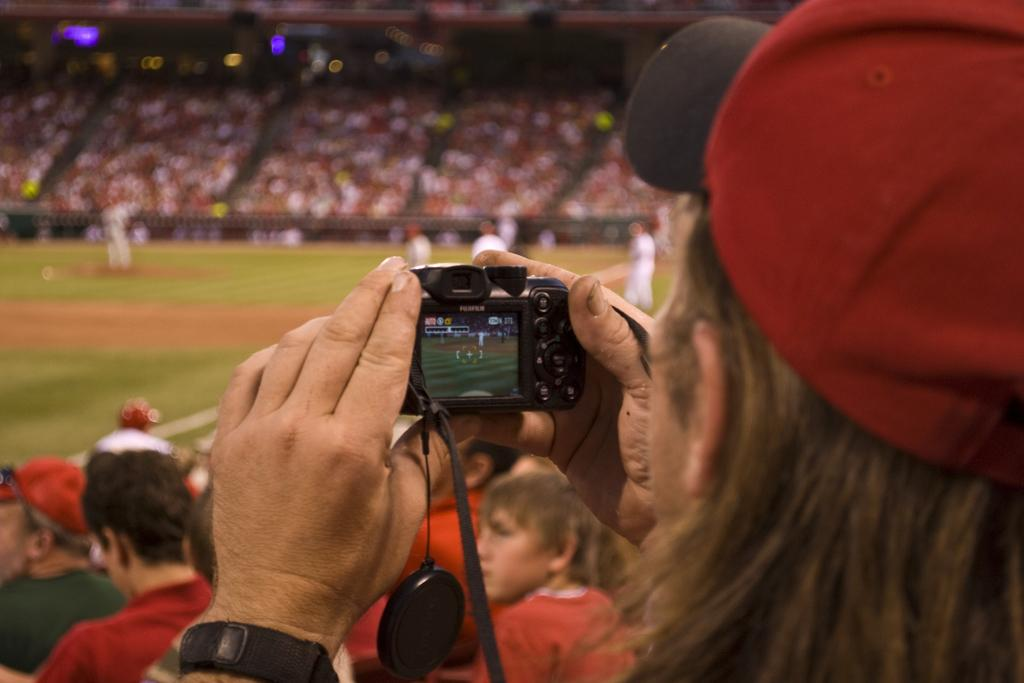What is the main subject of the image? The main subject of the image is a crowd. Can you describe the woman in the image? The woman is holding a camera with her hands and wearing a red color hat. She also has a band on her left hand. What might the woman be doing in the image? The woman might be taking pictures of the crowd with her camera. What effect does the band on the woman's left hand have on the crowd in the image? There is no information provided about the band's effect on the crowd, and therefore we cannot determine its impact. 